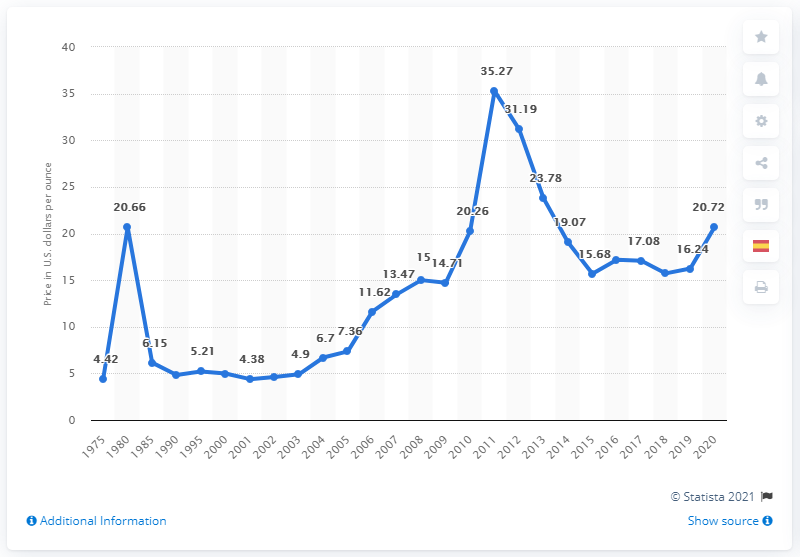Highlight a few significant elements in this photo. In 2020, the average price of silver per ounce was 20.72 dollars. 